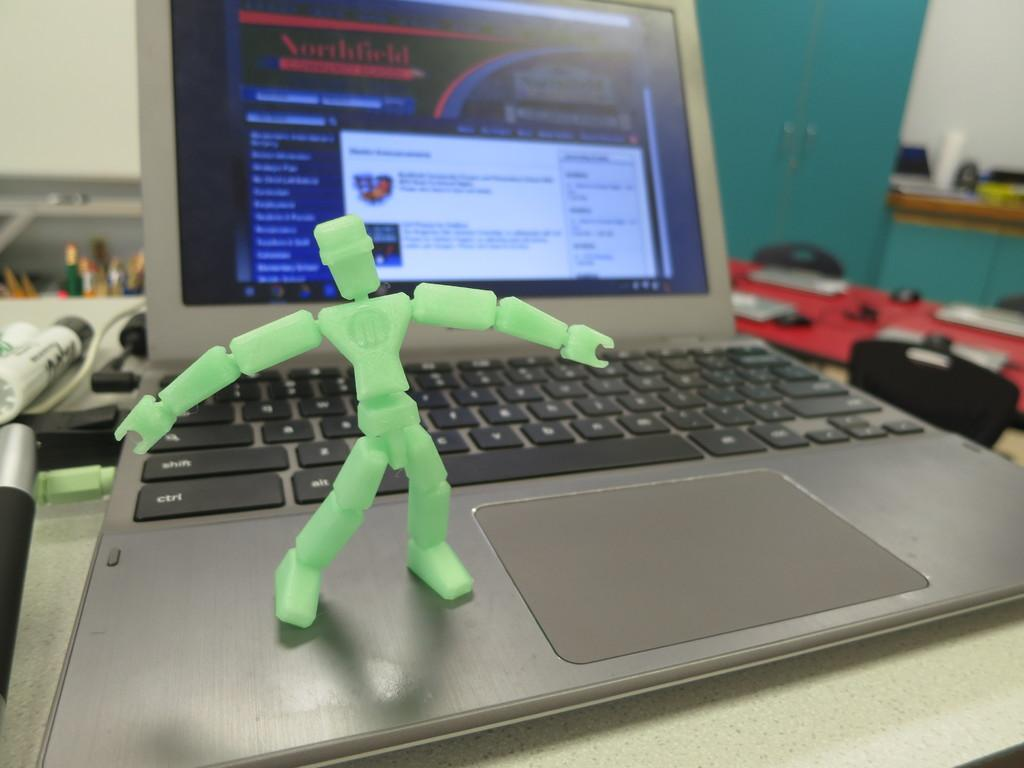Provide a one-sentence caption for the provided image. a green figure with letter M on the body is standing on a laptop. 